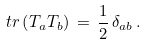<formula> <loc_0><loc_0><loc_500><loc_500>\ t r \left ( T _ { a } T _ { b } \right ) \, = \, \frac { 1 } { 2 } \, \delta _ { a b } \, .</formula> 